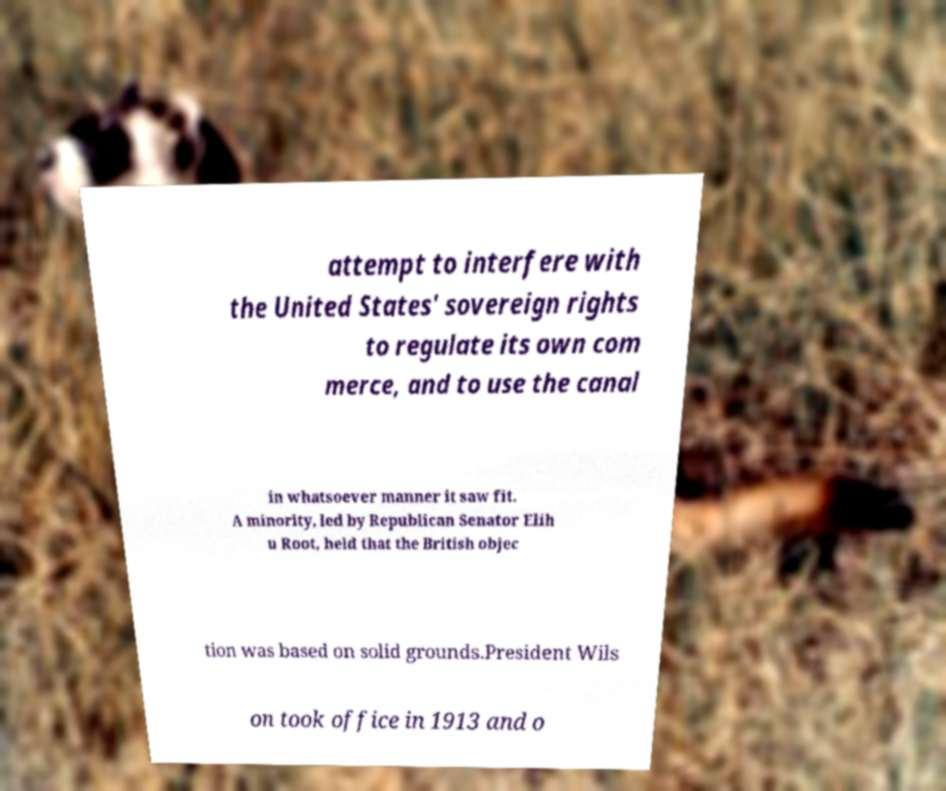Please read and relay the text visible in this image. What does it say? attempt to interfere with the United States' sovereign rights to regulate its own com merce, and to use the canal in whatsoever manner it saw fit. A minority, led by Republican Senator Elih u Root, held that the British objec tion was based on solid grounds.President Wils on took office in 1913 and o 